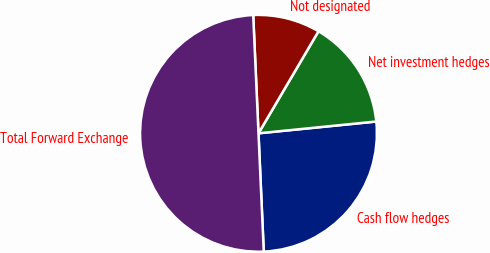<chart> <loc_0><loc_0><loc_500><loc_500><pie_chart><fcel>Cash flow hedges<fcel>Net investment hedges<fcel>Not designated<fcel>Total Forward Exchange<nl><fcel>25.88%<fcel>14.95%<fcel>9.17%<fcel>50.0%<nl></chart> 